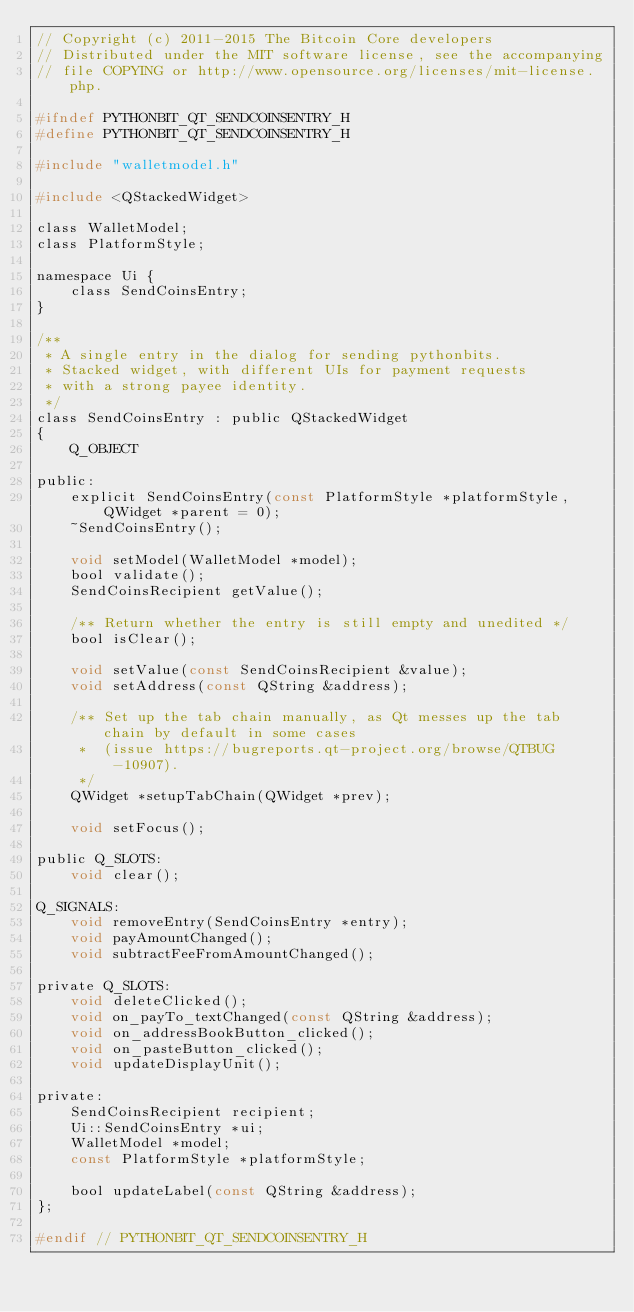<code> <loc_0><loc_0><loc_500><loc_500><_C_>// Copyright (c) 2011-2015 The Bitcoin Core developers
// Distributed under the MIT software license, see the accompanying
// file COPYING or http://www.opensource.org/licenses/mit-license.php.

#ifndef PYTHONBIT_QT_SENDCOINSENTRY_H
#define PYTHONBIT_QT_SENDCOINSENTRY_H

#include "walletmodel.h"

#include <QStackedWidget>

class WalletModel;
class PlatformStyle;

namespace Ui {
    class SendCoinsEntry;
}

/**
 * A single entry in the dialog for sending pythonbits.
 * Stacked widget, with different UIs for payment requests
 * with a strong payee identity.
 */
class SendCoinsEntry : public QStackedWidget
{
    Q_OBJECT

public:
    explicit SendCoinsEntry(const PlatformStyle *platformStyle, QWidget *parent = 0);
    ~SendCoinsEntry();

    void setModel(WalletModel *model);
    bool validate();
    SendCoinsRecipient getValue();

    /** Return whether the entry is still empty and unedited */
    bool isClear();

    void setValue(const SendCoinsRecipient &value);
    void setAddress(const QString &address);

    /** Set up the tab chain manually, as Qt messes up the tab chain by default in some cases
     *  (issue https://bugreports.qt-project.org/browse/QTBUG-10907).
     */
    QWidget *setupTabChain(QWidget *prev);

    void setFocus();

public Q_SLOTS:
    void clear();

Q_SIGNALS:
    void removeEntry(SendCoinsEntry *entry);
    void payAmountChanged();
    void subtractFeeFromAmountChanged();

private Q_SLOTS:
    void deleteClicked();
    void on_payTo_textChanged(const QString &address);
    void on_addressBookButton_clicked();
    void on_pasteButton_clicked();
    void updateDisplayUnit();

private:
    SendCoinsRecipient recipient;
    Ui::SendCoinsEntry *ui;
    WalletModel *model;
    const PlatformStyle *platformStyle;

    bool updateLabel(const QString &address);
};

#endif // PYTHONBIT_QT_SENDCOINSENTRY_H
</code> 